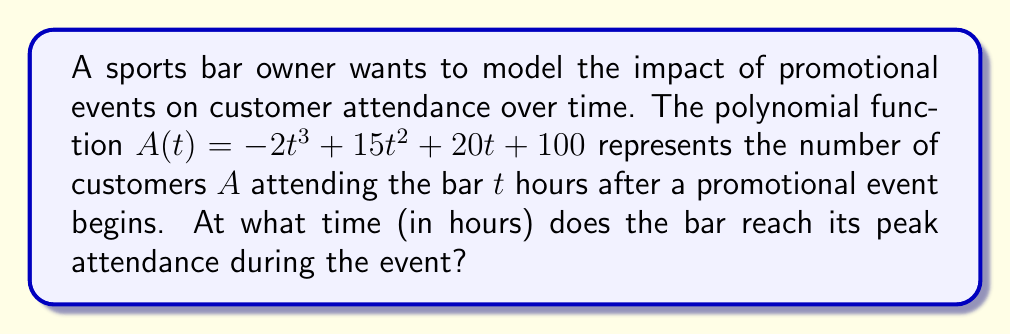Show me your answer to this math problem. To find the time of peak attendance, we need to determine the maximum point of the polynomial function. This can be done by following these steps:

1. Find the derivative of $A(t)$:
   $A'(t) = -6t^2 + 30t + 20$

2. Set the derivative equal to zero to find critical points:
   $-6t^2 + 30t + 20 = 0$

3. Solve the quadratic equation:
   $-6t^2 + 30t + 20 = 0$
   $-6(t^2 - 5t - \frac{10}{3}) = 0$
   $t^2 - 5t - \frac{10}{3} = 0$

   Using the quadratic formula: $t = \frac{-b \pm \sqrt{b^2 - 4ac}}{2a}$

   $t = \frac{5 \pm \sqrt{25 + \frac{80}{3}}}{2} = \frac{5 \pm \sqrt{\frac{155}{3}}}{2}$

4. Simplify and evaluate:
   $t_1 = \frac{5 + \sqrt{\frac{155}{3}}}{2} \approx 5.19$ hours
   $t_2 = \frac{5 - \sqrt{\frac{155}{3}}}{2} \approx -0.19$ hours

5. Check the second derivative to confirm the maximum:
   $A''(t) = -12t + 30$
   At $t = 5.19$: $A''(5.19) \approx -32.28 < 0$, confirming a maximum.

Therefore, the peak attendance occurs approximately 5.19 hours after the promotional event begins.
Answer: 5.19 hours 